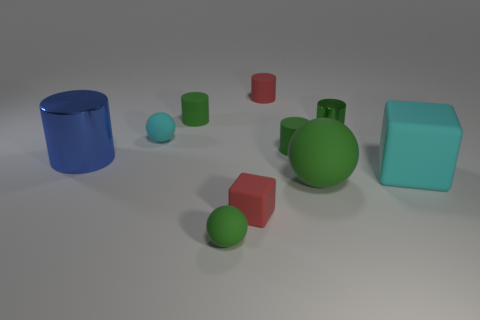What shape is the small matte thing that is the same color as the large cube? The small object sharing the same matte teal color as the large cube is a sphere. It's interesting to note how objects of the same color can drastically differ in shape—here the defined edges of the cube contrast against the smooth, continuous surface of the sphere. 